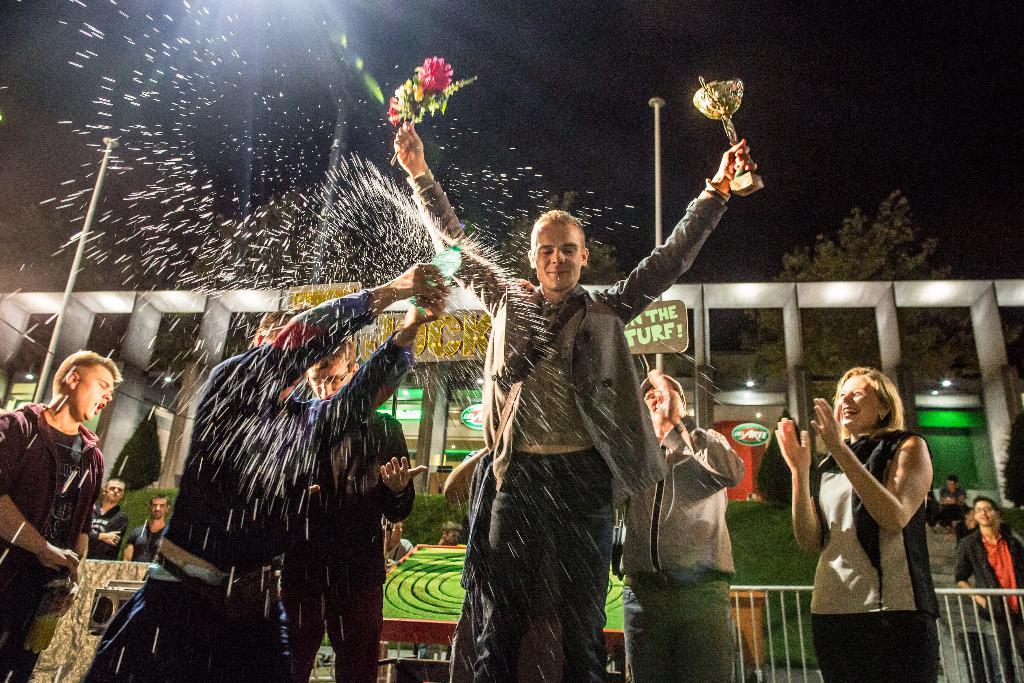Please provide a concise description of this image. In the image we can see there are people standing and wearing clothes. Some of them are smiling and carrying objects in hands. Here we can see poles, fence and grass. Here we can see lights, a tree and the sky 